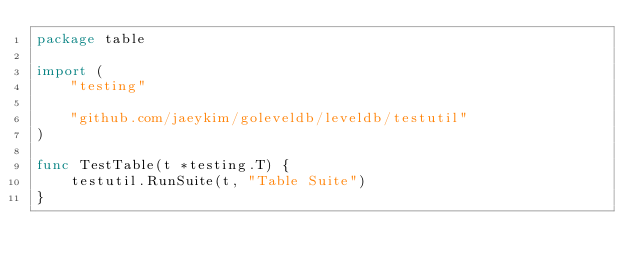Convert code to text. <code><loc_0><loc_0><loc_500><loc_500><_Go_>package table

import (
	"testing"

	"github.com/jaeykim/goleveldb/leveldb/testutil"
)

func TestTable(t *testing.T) {
	testutil.RunSuite(t, "Table Suite")
}
</code> 